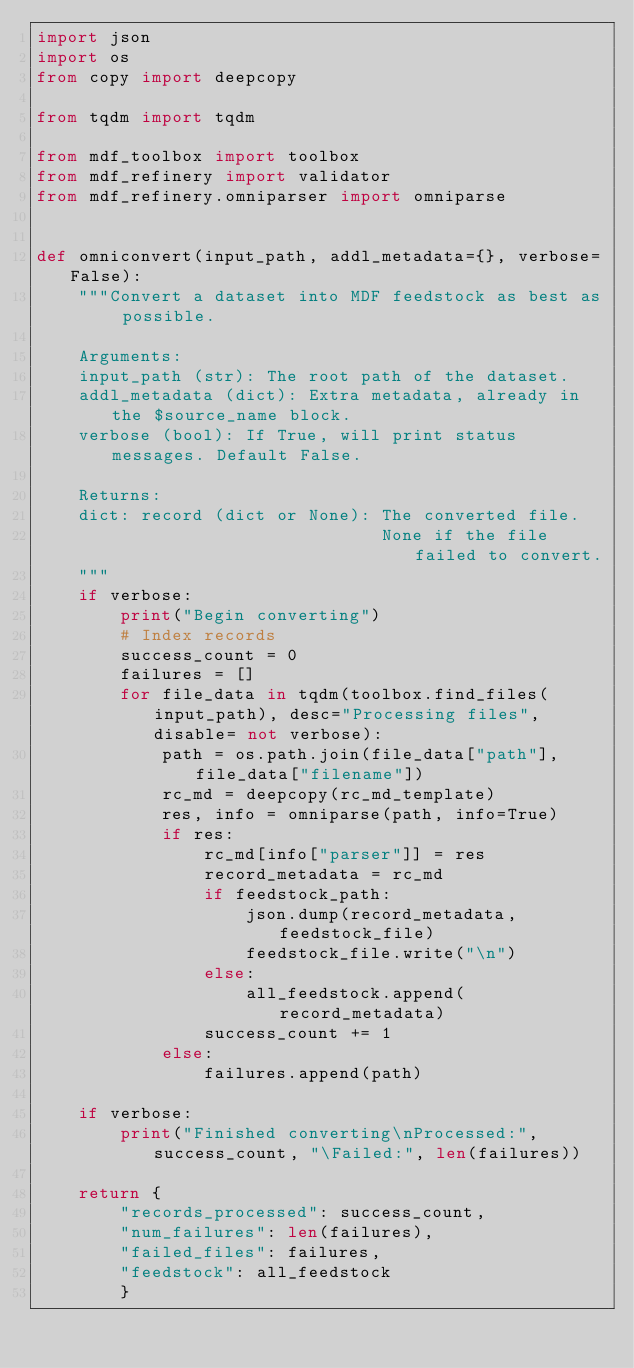Convert code to text. <code><loc_0><loc_0><loc_500><loc_500><_Python_>import json
import os
from copy import deepcopy

from tqdm import tqdm

from mdf_toolbox import toolbox
from mdf_refinery import validator
from mdf_refinery.omniparser import omniparse


def omniconvert(input_path, addl_metadata={}, verbose=False):
    """Convert a dataset into MDF feedstock as best as possible.

    Arguments:
    input_path (str): The root path of the dataset.
    addl_metadata (dict): Extra metadata, already in the $source_name block.
    verbose (bool): If True, will print status messages. Default False.

    Returns:
    dict: record (dict or None): The converted file.
                                 None if the file failed to convert.
    """
    if verbose:
        print("Begin converting")
        # Index records
        success_count = 0
        failures = []
        for file_data in tqdm(toolbox.find_files(input_path), desc="Processing files", disable= not verbose):
            path = os.path.join(file_data["path"], file_data["filename"])
            rc_md = deepcopy(rc_md_template)
            res, info = omniparse(path, info=True)
            if res:
                rc_md[info["parser"]] = res
                record_metadata = rc_md
                if feedstock_path:
                    json.dump(record_metadata, feedstock_file)
                    feedstock_file.write("\n")
                else:
                    all_feedstock.append(record_metadata)
                success_count += 1
            else:
                failures.append(path)

    if verbose:
        print("Finished converting\nProcessed:", success_count, "\Failed:", len(failures))

    return {
        "records_processed": success_count,
        "num_failures": len(failures),
        "failed_files": failures,
        "feedstock": all_feedstock
        }

</code> 